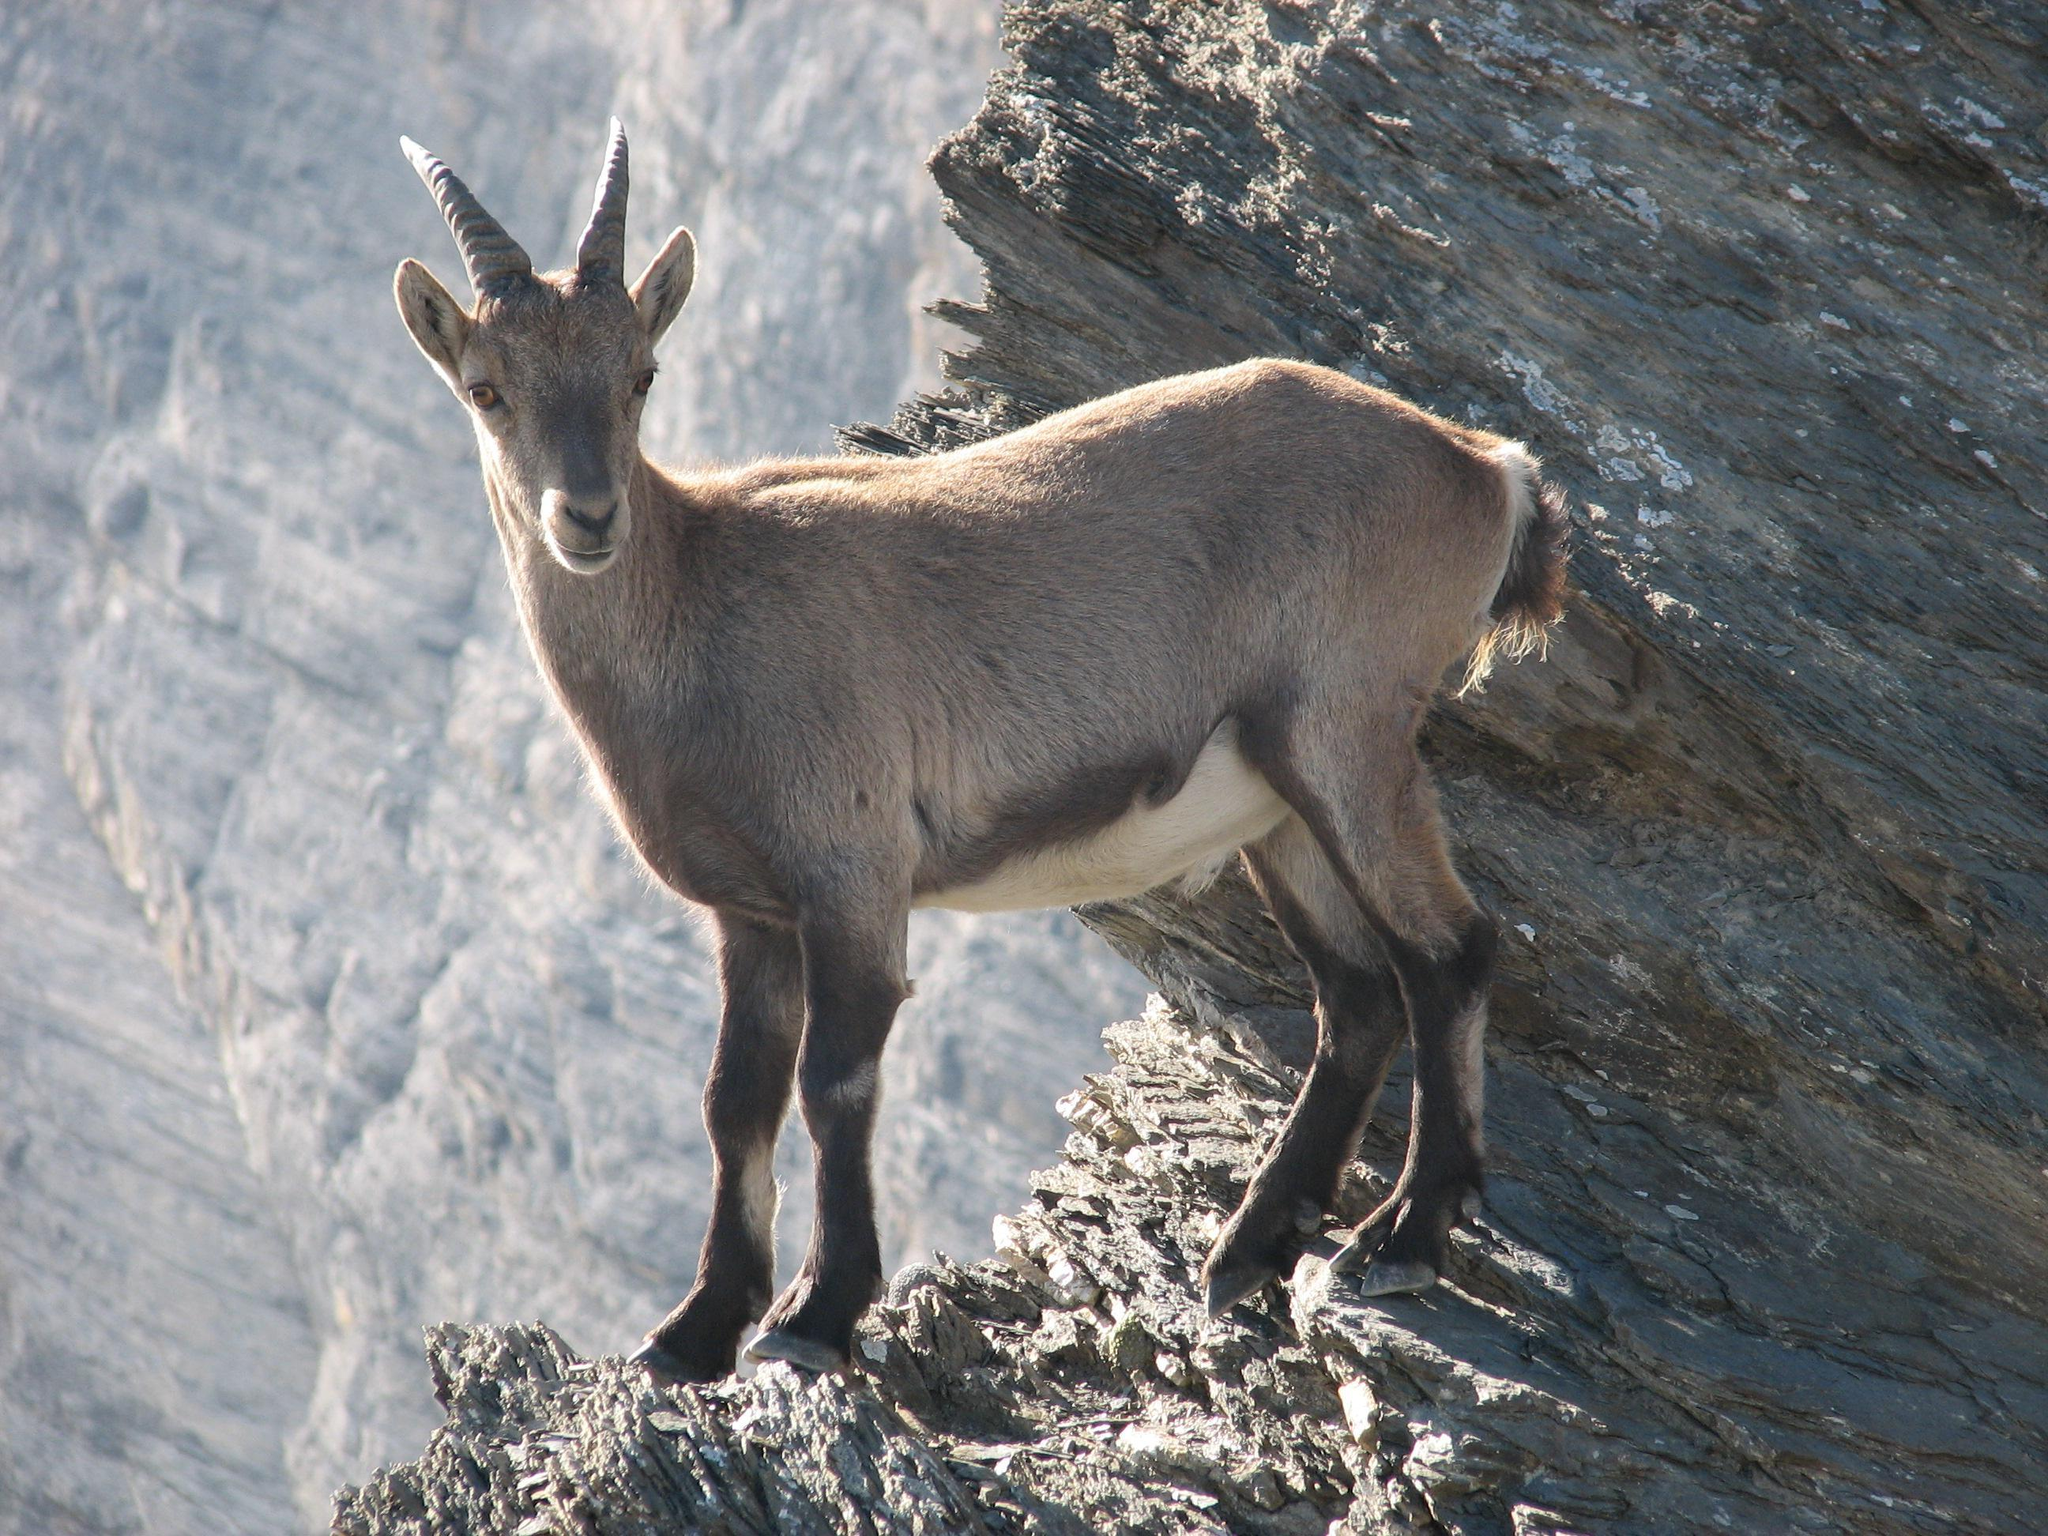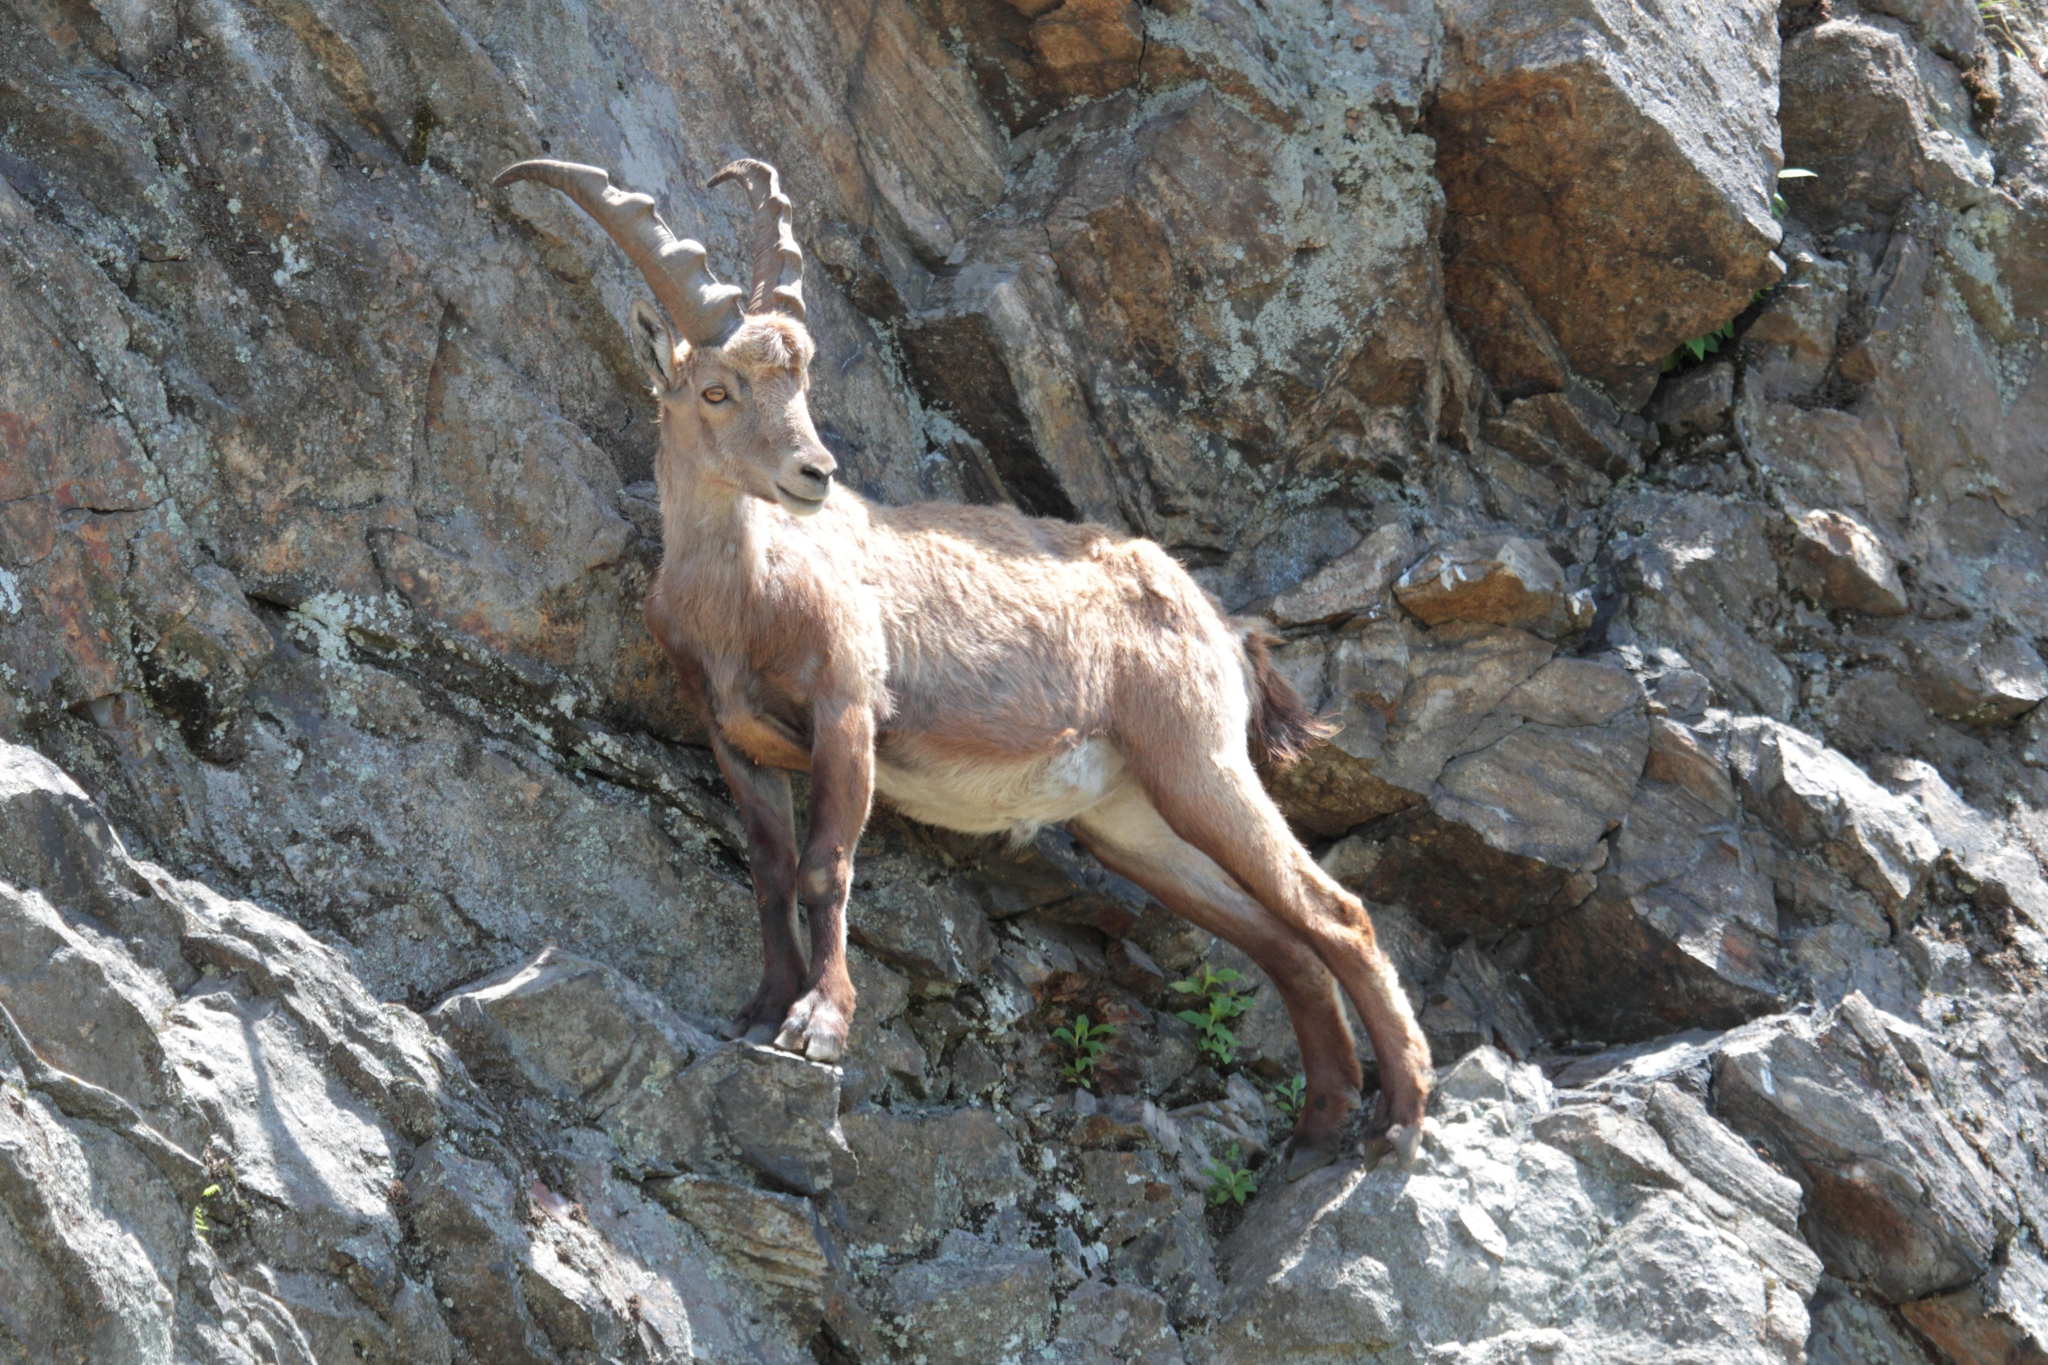The first image is the image on the left, the second image is the image on the right. Examine the images to the left and right. Is the description "There are at least two goats and none of them are on the grass." accurate? Answer yes or no. Yes. The first image is the image on the left, the second image is the image on the right. Examine the images to the left and right. Is the description "the sky is visible in the image on the right" accurate? Answer yes or no. No. 